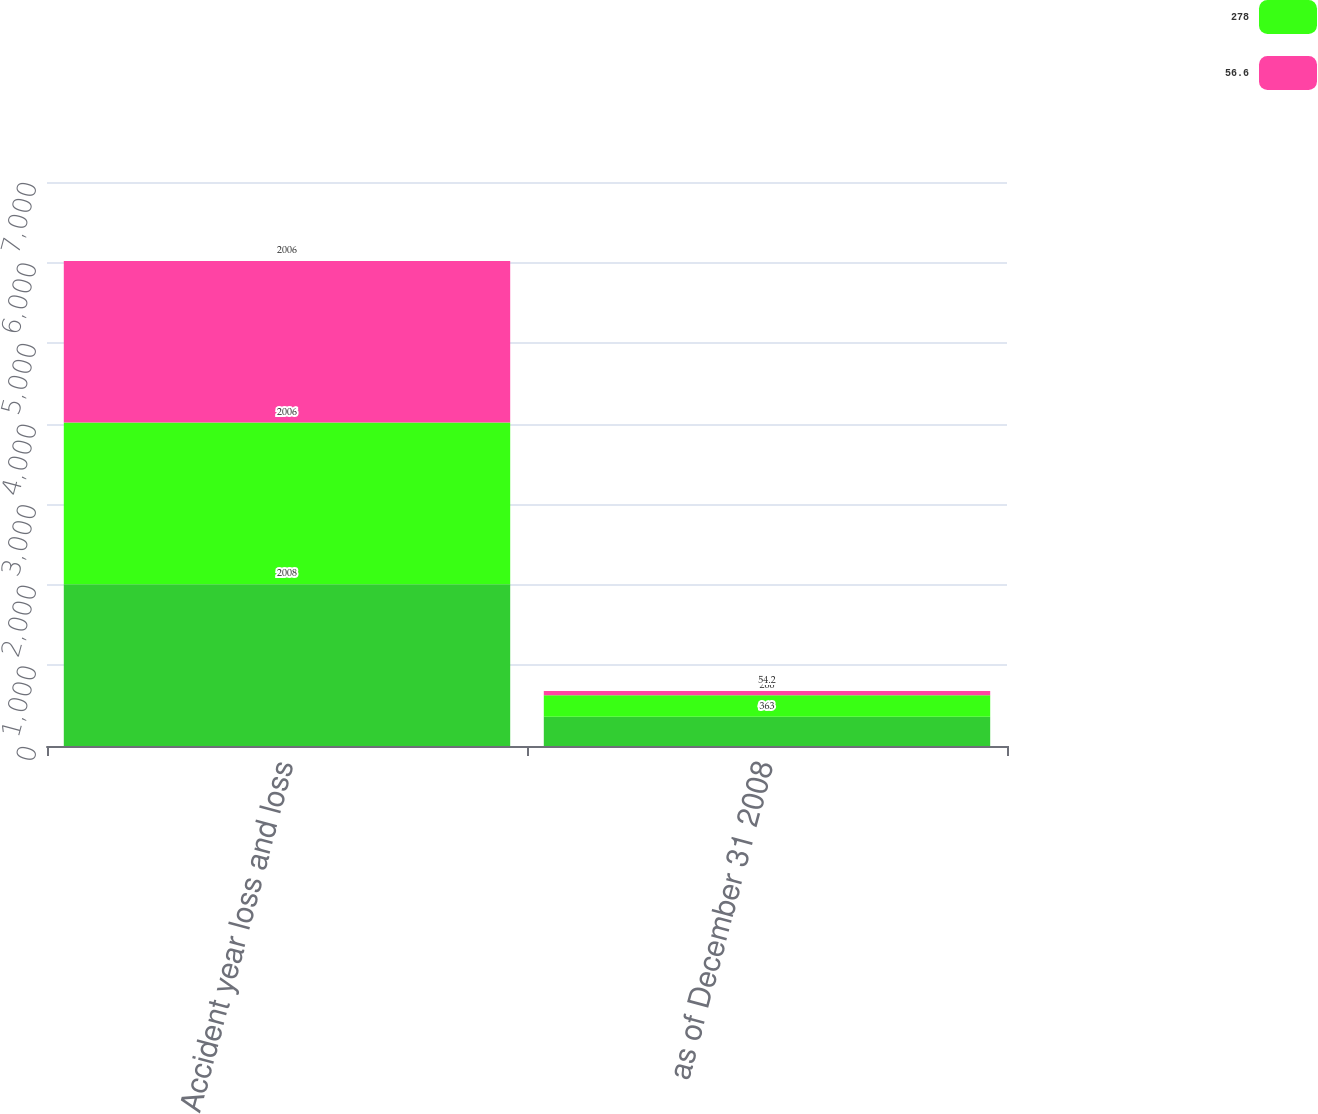Convert chart. <chart><loc_0><loc_0><loc_500><loc_500><stacked_bar_chart><ecel><fcel>Accident year loss and loss<fcel>as of December 31 2008<nl><fcel>nan<fcel>2008<fcel>363<nl><fcel>278<fcel>2006<fcel>266<nl><fcel>56.6<fcel>2006<fcel>54.2<nl></chart> 